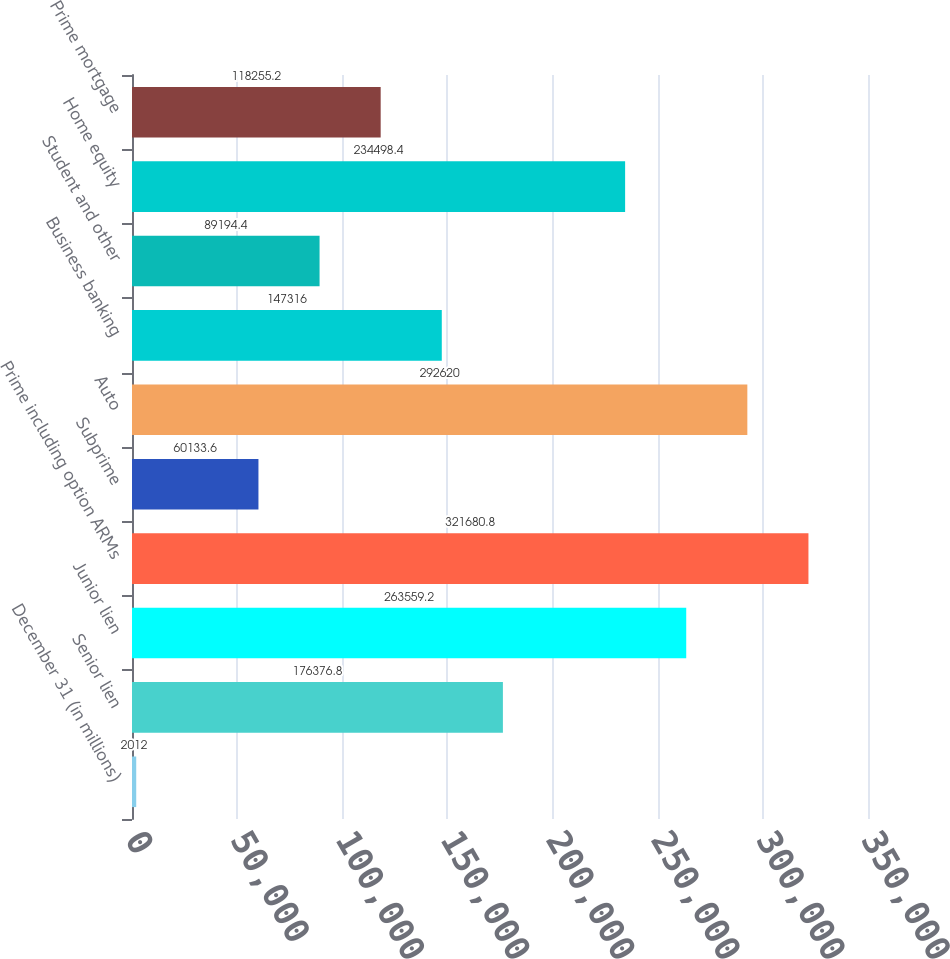<chart> <loc_0><loc_0><loc_500><loc_500><bar_chart><fcel>December 31 (in millions)<fcel>Senior lien<fcel>Junior lien<fcel>Prime including option ARMs<fcel>Subprime<fcel>Auto<fcel>Business banking<fcel>Student and other<fcel>Home equity<fcel>Prime mortgage<nl><fcel>2012<fcel>176377<fcel>263559<fcel>321681<fcel>60133.6<fcel>292620<fcel>147316<fcel>89194.4<fcel>234498<fcel>118255<nl></chart> 